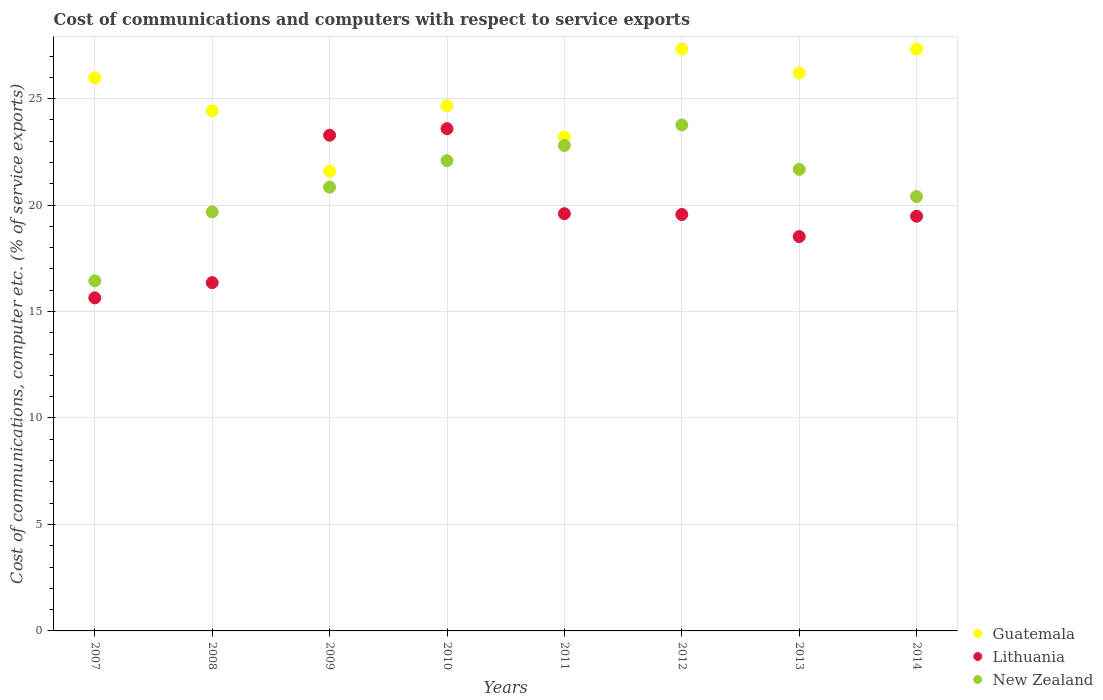Is the number of dotlines equal to the number of legend labels?
Provide a short and direct response. Yes. What is the cost of communications and computers in New Zealand in 2014?
Offer a terse response. 20.4. Across all years, what is the maximum cost of communications and computers in Lithuania?
Your answer should be compact. 23.59. Across all years, what is the minimum cost of communications and computers in Lithuania?
Keep it short and to the point. 15.64. What is the total cost of communications and computers in Guatemala in the graph?
Ensure brevity in your answer.  200.71. What is the difference between the cost of communications and computers in Lithuania in 2011 and that in 2013?
Ensure brevity in your answer.  1.08. What is the difference between the cost of communications and computers in New Zealand in 2014 and the cost of communications and computers in Lithuania in 2007?
Your response must be concise. 4.76. What is the average cost of communications and computers in New Zealand per year?
Offer a very short reply. 20.96. In the year 2010, what is the difference between the cost of communications and computers in Lithuania and cost of communications and computers in New Zealand?
Give a very brief answer. 1.5. What is the ratio of the cost of communications and computers in Lithuania in 2007 to that in 2009?
Your answer should be compact. 0.67. Is the difference between the cost of communications and computers in Lithuania in 2009 and 2013 greater than the difference between the cost of communications and computers in New Zealand in 2009 and 2013?
Your answer should be very brief. Yes. What is the difference between the highest and the second highest cost of communications and computers in New Zealand?
Make the answer very short. 0.96. What is the difference between the highest and the lowest cost of communications and computers in New Zealand?
Your response must be concise. 7.32. Is it the case that in every year, the sum of the cost of communications and computers in Guatemala and cost of communications and computers in New Zealand  is greater than the cost of communications and computers in Lithuania?
Provide a short and direct response. Yes. Is the cost of communications and computers in Guatemala strictly greater than the cost of communications and computers in New Zealand over the years?
Your answer should be very brief. Yes. How many dotlines are there?
Offer a terse response. 3. How many years are there in the graph?
Your answer should be very brief. 8. Are the values on the major ticks of Y-axis written in scientific E-notation?
Your response must be concise. No. How are the legend labels stacked?
Your answer should be very brief. Vertical. What is the title of the graph?
Give a very brief answer. Cost of communications and computers with respect to service exports. Does "Middle income" appear as one of the legend labels in the graph?
Your answer should be very brief. No. What is the label or title of the Y-axis?
Give a very brief answer. Cost of communications, computer etc. (% of service exports). What is the Cost of communications, computer etc. (% of service exports) of Guatemala in 2007?
Your answer should be compact. 25.98. What is the Cost of communications, computer etc. (% of service exports) in Lithuania in 2007?
Offer a terse response. 15.64. What is the Cost of communications, computer etc. (% of service exports) in New Zealand in 2007?
Offer a very short reply. 16.44. What is the Cost of communications, computer etc. (% of service exports) in Guatemala in 2008?
Your answer should be compact. 24.42. What is the Cost of communications, computer etc. (% of service exports) of Lithuania in 2008?
Provide a short and direct response. 16.36. What is the Cost of communications, computer etc. (% of service exports) of New Zealand in 2008?
Give a very brief answer. 19.68. What is the Cost of communications, computer etc. (% of service exports) of Guatemala in 2009?
Ensure brevity in your answer.  21.59. What is the Cost of communications, computer etc. (% of service exports) of Lithuania in 2009?
Provide a succinct answer. 23.28. What is the Cost of communications, computer etc. (% of service exports) in New Zealand in 2009?
Ensure brevity in your answer.  20.84. What is the Cost of communications, computer etc. (% of service exports) in Guatemala in 2010?
Your answer should be compact. 24.66. What is the Cost of communications, computer etc. (% of service exports) of Lithuania in 2010?
Give a very brief answer. 23.59. What is the Cost of communications, computer etc. (% of service exports) of New Zealand in 2010?
Your answer should be very brief. 22.08. What is the Cost of communications, computer etc. (% of service exports) in Guatemala in 2011?
Ensure brevity in your answer.  23.2. What is the Cost of communications, computer etc. (% of service exports) of Lithuania in 2011?
Offer a terse response. 19.6. What is the Cost of communications, computer etc. (% of service exports) in New Zealand in 2011?
Provide a succinct answer. 22.8. What is the Cost of communications, computer etc. (% of service exports) of Guatemala in 2012?
Give a very brief answer. 27.33. What is the Cost of communications, computer etc. (% of service exports) in Lithuania in 2012?
Offer a very short reply. 19.56. What is the Cost of communications, computer etc. (% of service exports) of New Zealand in 2012?
Your answer should be very brief. 23.76. What is the Cost of communications, computer etc. (% of service exports) in Guatemala in 2013?
Your answer should be compact. 26.2. What is the Cost of communications, computer etc. (% of service exports) in Lithuania in 2013?
Your response must be concise. 18.52. What is the Cost of communications, computer etc. (% of service exports) of New Zealand in 2013?
Offer a very short reply. 21.68. What is the Cost of communications, computer etc. (% of service exports) of Guatemala in 2014?
Your answer should be very brief. 27.33. What is the Cost of communications, computer etc. (% of service exports) of Lithuania in 2014?
Offer a terse response. 19.48. What is the Cost of communications, computer etc. (% of service exports) in New Zealand in 2014?
Ensure brevity in your answer.  20.4. Across all years, what is the maximum Cost of communications, computer etc. (% of service exports) in Guatemala?
Your answer should be very brief. 27.33. Across all years, what is the maximum Cost of communications, computer etc. (% of service exports) of Lithuania?
Keep it short and to the point. 23.59. Across all years, what is the maximum Cost of communications, computer etc. (% of service exports) of New Zealand?
Ensure brevity in your answer.  23.76. Across all years, what is the minimum Cost of communications, computer etc. (% of service exports) of Guatemala?
Provide a short and direct response. 21.59. Across all years, what is the minimum Cost of communications, computer etc. (% of service exports) of Lithuania?
Provide a short and direct response. 15.64. Across all years, what is the minimum Cost of communications, computer etc. (% of service exports) of New Zealand?
Make the answer very short. 16.44. What is the total Cost of communications, computer etc. (% of service exports) of Guatemala in the graph?
Offer a terse response. 200.71. What is the total Cost of communications, computer etc. (% of service exports) of Lithuania in the graph?
Offer a very short reply. 156.01. What is the total Cost of communications, computer etc. (% of service exports) of New Zealand in the graph?
Offer a terse response. 167.68. What is the difference between the Cost of communications, computer etc. (% of service exports) in Guatemala in 2007 and that in 2008?
Provide a succinct answer. 1.55. What is the difference between the Cost of communications, computer etc. (% of service exports) of Lithuania in 2007 and that in 2008?
Ensure brevity in your answer.  -0.71. What is the difference between the Cost of communications, computer etc. (% of service exports) in New Zealand in 2007 and that in 2008?
Keep it short and to the point. -3.24. What is the difference between the Cost of communications, computer etc. (% of service exports) in Guatemala in 2007 and that in 2009?
Offer a terse response. 4.38. What is the difference between the Cost of communications, computer etc. (% of service exports) of Lithuania in 2007 and that in 2009?
Provide a succinct answer. -7.64. What is the difference between the Cost of communications, computer etc. (% of service exports) of New Zealand in 2007 and that in 2009?
Give a very brief answer. -4.4. What is the difference between the Cost of communications, computer etc. (% of service exports) in Guatemala in 2007 and that in 2010?
Provide a succinct answer. 1.31. What is the difference between the Cost of communications, computer etc. (% of service exports) in Lithuania in 2007 and that in 2010?
Provide a short and direct response. -7.94. What is the difference between the Cost of communications, computer etc. (% of service exports) in New Zealand in 2007 and that in 2010?
Your answer should be compact. -5.64. What is the difference between the Cost of communications, computer etc. (% of service exports) in Guatemala in 2007 and that in 2011?
Provide a short and direct response. 2.78. What is the difference between the Cost of communications, computer etc. (% of service exports) in Lithuania in 2007 and that in 2011?
Give a very brief answer. -3.95. What is the difference between the Cost of communications, computer etc. (% of service exports) in New Zealand in 2007 and that in 2011?
Provide a short and direct response. -6.36. What is the difference between the Cost of communications, computer etc. (% of service exports) in Guatemala in 2007 and that in 2012?
Provide a succinct answer. -1.35. What is the difference between the Cost of communications, computer etc. (% of service exports) in Lithuania in 2007 and that in 2012?
Make the answer very short. -3.91. What is the difference between the Cost of communications, computer etc. (% of service exports) in New Zealand in 2007 and that in 2012?
Keep it short and to the point. -7.32. What is the difference between the Cost of communications, computer etc. (% of service exports) in Guatemala in 2007 and that in 2013?
Your answer should be compact. -0.23. What is the difference between the Cost of communications, computer etc. (% of service exports) of Lithuania in 2007 and that in 2013?
Your response must be concise. -2.88. What is the difference between the Cost of communications, computer etc. (% of service exports) of New Zealand in 2007 and that in 2013?
Give a very brief answer. -5.24. What is the difference between the Cost of communications, computer etc. (% of service exports) in Guatemala in 2007 and that in 2014?
Give a very brief answer. -1.35. What is the difference between the Cost of communications, computer etc. (% of service exports) in Lithuania in 2007 and that in 2014?
Offer a very short reply. -3.83. What is the difference between the Cost of communications, computer etc. (% of service exports) of New Zealand in 2007 and that in 2014?
Provide a short and direct response. -3.96. What is the difference between the Cost of communications, computer etc. (% of service exports) in Guatemala in 2008 and that in 2009?
Your answer should be very brief. 2.83. What is the difference between the Cost of communications, computer etc. (% of service exports) in Lithuania in 2008 and that in 2009?
Your answer should be very brief. -6.92. What is the difference between the Cost of communications, computer etc. (% of service exports) in New Zealand in 2008 and that in 2009?
Provide a short and direct response. -1.16. What is the difference between the Cost of communications, computer etc. (% of service exports) in Guatemala in 2008 and that in 2010?
Offer a terse response. -0.24. What is the difference between the Cost of communications, computer etc. (% of service exports) in Lithuania in 2008 and that in 2010?
Provide a short and direct response. -7.23. What is the difference between the Cost of communications, computer etc. (% of service exports) of New Zealand in 2008 and that in 2010?
Offer a very short reply. -2.4. What is the difference between the Cost of communications, computer etc. (% of service exports) in Guatemala in 2008 and that in 2011?
Give a very brief answer. 1.22. What is the difference between the Cost of communications, computer etc. (% of service exports) in Lithuania in 2008 and that in 2011?
Your answer should be compact. -3.24. What is the difference between the Cost of communications, computer etc. (% of service exports) of New Zealand in 2008 and that in 2011?
Make the answer very short. -3.12. What is the difference between the Cost of communications, computer etc. (% of service exports) in Guatemala in 2008 and that in 2012?
Your response must be concise. -2.91. What is the difference between the Cost of communications, computer etc. (% of service exports) in Lithuania in 2008 and that in 2012?
Provide a succinct answer. -3.2. What is the difference between the Cost of communications, computer etc. (% of service exports) in New Zealand in 2008 and that in 2012?
Make the answer very short. -4.08. What is the difference between the Cost of communications, computer etc. (% of service exports) of Guatemala in 2008 and that in 2013?
Give a very brief answer. -1.78. What is the difference between the Cost of communications, computer etc. (% of service exports) of Lithuania in 2008 and that in 2013?
Keep it short and to the point. -2.16. What is the difference between the Cost of communications, computer etc. (% of service exports) of New Zealand in 2008 and that in 2013?
Offer a terse response. -2. What is the difference between the Cost of communications, computer etc. (% of service exports) in Guatemala in 2008 and that in 2014?
Your response must be concise. -2.9. What is the difference between the Cost of communications, computer etc. (% of service exports) of Lithuania in 2008 and that in 2014?
Provide a succinct answer. -3.12. What is the difference between the Cost of communications, computer etc. (% of service exports) of New Zealand in 2008 and that in 2014?
Your response must be concise. -0.72. What is the difference between the Cost of communications, computer etc. (% of service exports) in Guatemala in 2009 and that in 2010?
Make the answer very short. -3.07. What is the difference between the Cost of communications, computer etc. (% of service exports) in Lithuania in 2009 and that in 2010?
Ensure brevity in your answer.  -0.31. What is the difference between the Cost of communications, computer etc. (% of service exports) of New Zealand in 2009 and that in 2010?
Your answer should be very brief. -1.24. What is the difference between the Cost of communications, computer etc. (% of service exports) of Guatemala in 2009 and that in 2011?
Provide a short and direct response. -1.61. What is the difference between the Cost of communications, computer etc. (% of service exports) of Lithuania in 2009 and that in 2011?
Your answer should be very brief. 3.69. What is the difference between the Cost of communications, computer etc. (% of service exports) of New Zealand in 2009 and that in 2011?
Offer a terse response. -1.96. What is the difference between the Cost of communications, computer etc. (% of service exports) in Guatemala in 2009 and that in 2012?
Provide a short and direct response. -5.74. What is the difference between the Cost of communications, computer etc. (% of service exports) of Lithuania in 2009 and that in 2012?
Your answer should be compact. 3.72. What is the difference between the Cost of communications, computer etc. (% of service exports) of New Zealand in 2009 and that in 2012?
Make the answer very short. -2.92. What is the difference between the Cost of communications, computer etc. (% of service exports) of Guatemala in 2009 and that in 2013?
Offer a terse response. -4.61. What is the difference between the Cost of communications, computer etc. (% of service exports) in Lithuania in 2009 and that in 2013?
Give a very brief answer. 4.76. What is the difference between the Cost of communications, computer etc. (% of service exports) in New Zealand in 2009 and that in 2013?
Keep it short and to the point. -0.84. What is the difference between the Cost of communications, computer etc. (% of service exports) in Guatemala in 2009 and that in 2014?
Your answer should be very brief. -5.74. What is the difference between the Cost of communications, computer etc. (% of service exports) of Lithuania in 2009 and that in 2014?
Make the answer very short. 3.81. What is the difference between the Cost of communications, computer etc. (% of service exports) of New Zealand in 2009 and that in 2014?
Give a very brief answer. 0.44. What is the difference between the Cost of communications, computer etc. (% of service exports) in Guatemala in 2010 and that in 2011?
Offer a terse response. 1.47. What is the difference between the Cost of communications, computer etc. (% of service exports) in Lithuania in 2010 and that in 2011?
Make the answer very short. 3.99. What is the difference between the Cost of communications, computer etc. (% of service exports) in New Zealand in 2010 and that in 2011?
Make the answer very short. -0.72. What is the difference between the Cost of communications, computer etc. (% of service exports) of Guatemala in 2010 and that in 2012?
Your answer should be very brief. -2.67. What is the difference between the Cost of communications, computer etc. (% of service exports) in Lithuania in 2010 and that in 2012?
Provide a short and direct response. 4.03. What is the difference between the Cost of communications, computer etc. (% of service exports) in New Zealand in 2010 and that in 2012?
Ensure brevity in your answer.  -1.68. What is the difference between the Cost of communications, computer etc. (% of service exports) of Guatemala in 2010 and that in 2013?
Give a very brief answer. -1.54. What is the difference between the Cost of communications, computer etc. (% of service exports) of Lithuania in 2010 and that in 2013?
Provide a succinct answer. 5.07. What is the difference between the Cost of communications, computer etc. (% of service exports) in New Zealand in 2010 and that in 2013?
Keep it short and to the point. 0.41. What is the difference between the Cost of communications, computer etc. (% of service exports) in Guatemala in 2010 and that in 2014?
Keep it short and to the point. -2.66. What is the difference between the Cost of communications, computer etc. (% of service exports) of Lithuania in 2010 and that in 2014?
Give a very brief answer. 4.11. What is the difference between the Cost of communications, computer etc. (% of service exports) in New Zealand in 2010 and that in 2014?
Provide a short and direct response. 1.68. What is the difference between the Cost of communications, computer etc. (% of service exports) in Guatemala in 2011 and that in 2012?
Provide a short and direct response. -4.13. What is the difference between the Cost of communications, computer etc. (% of service exports) in Lithuania in 2011 and that in 2012?
Give a very brief answer. 0.04. What is the difference between the Cost of communications, computer etc. (% of service exports) of New Zealand in 2011 and that in 2012?
Your answer should be very brief. -0.96. What is the difference between the Cost of communications, computer etc. (% of service exports) of Guatemala in 2011 and that in 2013?
Provide a succinct answer. -3.01. What is the difference between the Cost of communications, computer etc. (% of service exports) in Lithuania in 2011 and that in 2013?
Offer a very short reply. 1.08. What is the difference between the Cost of communications, computer etc. (% of service exports) in New Zealand in 2011 and that in 2013?
Give a very brief answer. 1.12. What is the difference between the Cost of communications, computer etc. (% of service exports) in Guatemala in 2011 and that in 2014?
Your answer should be very brief. -4.13. What is the difference between the Cost of communications, computer etc. (% of service exports) of Lithuania in 2011 and that in 2014?
Offer a terse response. 0.12. What is the difference between the Cost of communications, computer etc. (% of service exports) of New Zealand in 2011 and that in 2014?
Ensure brevity in your answer.  2.4. What is the difference between the Cost of communications, computer etc. (% of service exports) of Lithuania in 2012 and that in 2013?
Offer a terse response. 1.04. What is the difference between the Cost of communications, computer etc. (% of service exports) of New Zealand in 2012 and that in 2013?
Offer a very short reply. 2.08. What is the difference between the Cost of communications, computer etc. (% of service exports) of Guatemala in 2012 and that in 2014?
Give a very brief answer. 0. What is the difference between the Cost of communications, computer etc. (% of service exports) of Lithuania in 2012 and that in 2014?
Your answer should be compact. 0.08. What is the difference between the Cost of communications, computer etc. (% of service exports) in New Zealand in 2012 and that in 2014?
Give a very brief answer. 3.36. What is the difference between the Cost of communications, computer etc. (% of service exports) in Guatemala in 2013 and that in 2014?
Your response must be concise. -1.12. What is the difference between the Cost of communications, computer etc. (% of service exports) of Lithuania in 2013 and that in 2014?
Provide a short and direct response. -0.96. What is the difference between the Cost of communications, computer etc. (% of service exports) in New Zealand in 2013 and that in 2014?
Provide a short and direct response. 1.28. What is the difference between the Cost of communications, computer etc. (% of service exports) in Guatemala in 2007 and the Cost of communications, computer etc. (% of service exports) in Lithuania in 2008?
Provide a short and direct response. 9.62. What is the difference between the Cost of communications, computer etc. (% of service exports) in Guatemala in 2007 and the Cost of communications, computer etc. (% of service exports) in New Zealand in 2008?
Make the answer very short. 6.3. What is the difference between the Cost of communications, computer etc. (% of service exports) in Lithuania in 2007 and the Cost of communications, computer etc. (% of service exports) in New Zealand in 2008?
Your answer should be very brief. -4.04. What is the difference between the Cost of communications, computer etc. (% of service exports) of Guatemala in 2007 and the Cost of communications, computer etc. (% of service exports) of Lithuania in 2009?
Offer a very short reply. 2.7. What is the difference between the Cost of communications, computer etc. (% of service exports) in Guatemala in 2007 and the Cost of communications, computer etc. (% of service exports) in New Zealand in 2009?
Ensure brevity in your answer.  5.14. What is the difference between the Cost of communications, computer etc. (% of service exports) in Lithuania in 2007 and the Cost of communications, computer etc. (% of service exports) in New Zealand in 2009?
Your answer should be compact. -5.2. What is the difference between the Cost of communications, computer etc. (% of service exports) of Guatemala in 2007 and the Cost of communications, computer etc. (% of service exports) of Lithuania in 2010?
Keep it short and to the point. 2.39. What is the difference between the Cost of communications, computer etc. (% of service exports) in Guatemala in 2007 and the Cost of communications, computer etc. (% of service exports) in New Zealand in 2010?
Your response must be concise. 3.89. What is the difference between the Cost of communications, computer etc. (% of service exports) of Lithuania in 2007 and the Cost of communications, computer etc. (% of service exports) of New Zealand in 2010?
Your response must be concise. -6.44. What is the difference between the Cost of communications, computer etc. (% of service exports) of Guatemala in 2007 and the Cost of communications, computer etc. (% of service exports) of Lithuania in 2011?
Your answer should be compact. 6.38. What is the difference between the Cost of communications, computer etc. (% of service exports) of Guatemala in 2007 and the Cost of communications, computer etc. (% of service exports) of New Zealand in 2011?
Offer a very short reply. 3.18. What is the difference between the Cost of communications, computer etc. (% of service exports) in Lithuania in 2007 and the Cost of communications, computer etc. (% of service exports) in New Zealand in 2011?
Provide a short and direct response. -7.16. What is the difference between the Cost of communications, computer etc. (% of service exports) of Guatemala in 2007 and the Cost of communications, computer etc. (% of service exports) of Lithuania in 2012?
Make the answer very short. 6.42. What is the difference between the Cost of communications, computer etc. (% of service exports) in Guatemala in 2007 and the Cost of communications, computer etc. (% of service exports) in New Zealand in 2012?
Keep it short and to the point. 2.22. What is the difference between the Cost of communications, computer etc. (% of service exports) of Lithuania in 2007 and the Cost of communications, computer etc. (% of service exports) of New Zealand in 2012?
Make the answer very short. -8.12. What is the difference between the Cost of communications, computer etc. (% of service exports) of Guatemala in 2007 and the Cost of communications, computer etc. (% of service exports) of Lithuania in 2013?
Your answer should be compact. 7.46. What is the difference between the Cost of communications, computer etc. (% of service exports) in Guatemala in 2007 and the Cost of communications, computer etc. (% of service exports) in New Zealand in 2013?
Your answer should be compact. 4.3. What is the difference between the Cost of communications, computer etc. (% of service exports) in Lithuania in 2007 and the Cost of communications, computer etc. (% of service exports) in New Zealand in 2013?
Give a very brief answer. -6.03. What is the difference between the Cost of communications, computer etc. (% of service exports) in Guatemala in 2007 and the Cost of communications, computer etc. (% of service exports) in Lithuania in 2014?
Keep it short and to the point. 6.5. What is the difference between the Cost of communications, computer etc. (% of service exports) of Guatemala in 2007 and the Cost of communications, computer etc. (% of service exports) of New Zealand in 2014?
Ensure brevity in your answer.  5.58. What is the difference between the Cost of communications, computer etc. (% of service exports) of Lithuania in 2007 and the Cost of communications, computer etc. (% of service exports) of New Zealand in 2014?
Provide a succinct answer. -4.76. What is the difference between the Cost of communications, computer etc. (% of service exports) of Guatemala in 2008 and the Cost of communications, computer etc. (% of service exports) of New Zealand in 2009?
Provide a short and direct response. 3.58. What is the difference between the Cost of communications, computer etc. (% of service exports) of Lithuania in 2008 and the Cost of communications, computer etc. (% of service exports) of New Zealand in 2009?
Provide a short and direct response. -4.48. What is the difference between the Cost of communications, computer etc. (% of service exports) of Guatemala in 2008 and the Cost of communications, computer etc. (% of service exports) of Lithuania in 2010?
Offer a very short reply. 0.84. What is the difference between the Cost of communications, computer etc. (% of service exports) in Guatemala in 2008 and the Cost of communications, computer etc. (% of service exports) in New Zealand in 2010?
Offer a terse response. 2.34. What is the difference between the Cost of communications, computer etc. (% of service exports) of Lithuania in 2008 and the Cost of communications, computer etc. (% of service exports) of New Zealand in 2010?
Your answer should be very brief. -5.73. What is the difference between the Cost of communications, computer etc. (% of service exports) in Guatemala in 2008 and the Cost of communications, computer etc. (% of service exports) in Lithuania in 2011?
Offer a very short reply. 4.83. What is the difference between the Cost of communications, computer etc. (% of service exports) in Guatemala in 2008 and the Cost of communications, computer etc. (% of service exports) in New Zealand in 2011?
Ensure brevity in your answer.  1.62. What is the difference between the Cost of communications, computer etc. (% of service exports) of Lithuania in 2008 and the Cost of communications, computer etc. (% of service exports) of New Zealand in 2011?
Provide a short and direct response. -6.44. What is the difference between the Cost of communications, computer etc. (% of service exports) in Guatemala in 2008 and the Cost of communications, computer etc. (% of service exports) in Lithuania in 2012?
Give a very brief answer. 4.87. What is the difference between the Cost of communications, computer etc. (% of service exports) of Guatemala in 2008 and the Cost of communications, computer etc. (% of service exports) of New Zealand in 2012?
Ensure brevity in your answer.  0.66. What is the difference between the Cost of communications, computer etc. (% of service exports) of Lithuania in 2008 and the Cost of communications, computer etc. (% of service exports) of New Zealand in 2012?
Your response must be concise. -7.4. What is the difference between the Cost of communications, computer etc. (% of service exports) of Guatemala in 2008 and the Cost of communications, computer etc. (% of service exports) of Lithuania in 2013?
Make the answer very short. 5.9. What is the difference between the Cost of communications, computer etc. (% of service exports) in Guatemala in 2008 and the Cost of communications, computer etc. (% of service exports) in New Zealand in 2013?
Offer a very short reply. 2.75. What is the difference between the Cost of communications, computer etc. (% of service exports) in Lithuania in 2008 and the Cost of communications, computer etc. (% of service exports) in New Zealand in 2013?
Make the answer very short. -5.32. What is the difference between the Cost of communications, computer etc. (% of service exports) of Guatemala in 2008 and the Cost of communications, computer etc. (% of service exports) of Lithuania in 2014?
Your answer should be compact. 4.95. What is the difference between the Cost of communications, computer etc. (% of service exports) of Guatemala in 2008 and the Cost of communications, computer etc. (% of service exports) of New Zealand in 2014?
Make the answer very short. 4.02. What is the difference between the Cost of communications, computer etc. (% of service exports) of Lithuania in 2008 and the Cost of communications, computer etc. (% of service exports) of New Zealand in 2014?
Keep it short and to the point. -4.04. What is the difference between the Cost of communications, computer etc. (% of service exports) of Guatemala in 2009 and the Cost of communications, computer etc. (% of service exports) of Lithuania in 2010?
Offer a very short reply. -2. What is the difference between the Cost of communications, computer etc. (% of service exports) in Guatemala in 2009 and the Cost of communications, computer etc. (% of service exports) in New Zealand in 2010?
Your response must be concise. -0.49. What is the difference between the Cost of communications, computer etc. (% of service exports) of Lithuania in 2009 and the Cost of communications, computer etc. (% of service exports) of New Zealand in 2010?
Provide a succinct answer. 1.2. What is the difference between the Cost of communications, computer etc. (% of service exports) of Guatemala in 2009 and the Cost of communications, computer etc. (% of service exports) of Lithuania in 2011?
Provide a succinct answer. 2. What is the difference between the Cost of communications, computer etc. (% of service exports) of Guatemala in 2009 and the Cost of communications, computer etc. (% of service exports) of New Zealand in 2011?
Give a very brief answer. -1.21. What is the difference between the Cost of communications, computer etc. (% of service exports) in Lithuania in 2009 and the Cost of communications, computer etc. (% of service exports) in New Zealand in 2011?
Provide a short and direct response. 0.48. What is the difference between the Cost of communications, computer etc. (% of service exports) in Guatemala in 2009 and the Cost of communications, computer etc. (% of service exports) in Lithuania in 2012?
Your answer should be very brief. 2.03. What is the difference between the Cost of communications, computer etc. (% of service exports) of Guatemala in 2009 and the Cost of communications, computer etc. (% of service exports) of New Zealand in 2012?
Provide a succinct answer. -2.17. What is the difference between the Cost of communications, computer etc. (% of service exports) in Lithuania in 2009 and the Cost of communications, computer etc. (% of service exports) in New Zealand in 2012?
Provide a short and direct response. -0.48. What is the difference between the Cost of communications, computer etc. (% of service exports) in Guatemala in 2009 and the Cost of communications, computer etc. (% of service exports) in Lithuania in 2013?
Give a very brief answer. 3.07. What is the difference between the Cost of communications, computer etc. (% of service exports) of Guatemala in 2009 and the Cost of communications, computer etc. (% of service exports) of New Zealand in 2013?
Your answer should be very brief. -0.09. What is the difference between the Cost of communications, computer etc. (% of service exports) of Lithuania in 2009 and the Cost of communications, computer etc. (% of service exports) of New Zealand in 2013?
Your answer should be very brief. 1.6. What is the difference between the Cost of communications, computer etc. (% of service exports) in Guatemala in 2009 and the Cost of communications, computer etc. (% of service exports) in Lithuania in 2014?
Offer a terse response. 2.12. What is the difference between the Cost of communications, computer etc. (% of service exports) of Guatemala in 2009 and the Cost of communications, computer etc. (% of service exports) of New Zealand in 2014?
Make the answer very short. 1.19. What is the difference between the Cost of communications, computer etc. (% of service exports) of Lithuania in 2009 and the Cost of communications, computer etc. (% of service exports) of New Zealand in 2014?
Provide a short and direct response. 2.88. What is the difference between the Cost of communications, computer etc. (% of service exports) of Guatemala in 2010 and the Cost of communications, computer etc. (% of service exports) of Lithuania in 2011?
Give a very brief answer. 5.07. What is the difference between the Cost of communications, computer etc. (% of service exports) in Guatemala in 2010 and the Cost of communications, computer etc. (% of service exports) in New Zealand in 2011?
Provide a short and direct response. 1.86. What is the difference between the Cost of communications, computer etc. (% of service exports) of Lithuania in 2010 and the Cost of communications, computer etc. (% of service exports) of New Zealand in 2011?
Your response must be concise. 0.79. What is the difference between the Cost of communications, computer etc. (% of service exports) in Guatemala in 2010 and the Cost of communications, computer etc. (% of service exports) in Lithuania in 2012?
Your response must be concise. 5.11. What is the difference between the Cost of communications, computer etc. (% of service exports) in Guatemala in 2010 and the Cost of communications, computer etc. (% of service exports) in New Zealand in 2012?
Make the answer very short. 0.9. What is the difference between the Cost of communications, computer etc. (% of service exports) in Lithuania in 2010 and the Cost of communications, computer etc. (% of service exports) in New Zealand in 2012?
Offer a terse response. -0.17. What is the difference between the Cost of communications, computer etc. (% of service exports) of Guatemala in 2010 and the Cost of communications, computer etc. (% of service exports) of Lithuania in 2013?
Your answer should be compact. 6.14. What is the difference between the Cost of communications, computer etc. (% of service exports) in Guatemala in 2010 and the Cost of communications, computer etc. (% of service exports) in New Zealand in 2013?
Your response must be concise. 2.99. What is the difference between the Cost of communications, computer etc. (% of service exports) of Lithuania in 2010 and the Cost of communications, computer etc. (% of service exports) of New Zealand in 2013?
Offer a terse response. 1.91. What is the difference between the Cost of communications, computer etc. (% of service exports) in Guatemala in 2010 and the Cost of communications, computer etc. (% of service exports) in Lithuania in 2014?
Keep it short and to the point. 5.19. What is the difference between the Cost of communications, computer etc. (% of service exports) of Guatemala in 2010 and the Cost of communications, computer etc. (% of service exports) of New Zealand in 2014?
Offer a very short reply. 4.26. What is the difference between the Cost of communications, computer etc. (% of service exports) in Lithuania in 2010 and the Cost of communications, computer etc. (% of service exports) in New Zealand in 2014?
Make the answer very short. 3.19. What is the difference between the Cost of communications, computer etc. (% of service exports) of Guatemala in 2011 and the Cost of communications, computer etc. (% of service exports) of Lithuania in 2012?
Provide a short and direct response. 3.64. What is the difference between the Cost of communications, computer etc. (% of service exports) in Guatemala in 2011 and the Cost of communications, computer etc. (% of service exports) in New Zealand in 2012?
Give a very brief answer. -0.56. What is the difference between the Cost of communications, computer etc. (% of service exports) of Lithuania in 2011 and the Cost of communications, computer etc. (% of service exports) of New Zealand in 2012?
Provide a succinct answer. -4.17. What is the difference between the Cost of communications, computer etc. (% of service exports) of Guatemala in 2011 and the Cost of communications, computer etc. (% of service exports) of Lithuania in 2013?
Make the answer very short. 4.68. What is the difference between the Cost of communications, computer etc. (% of service exports) of Guatemala in 2011 and the Cost of communications, computer etc. (% of service exports) of New Zealand in 2013?
Offer a very short reply. 1.52. What is the difference between the Cost of communications, computer etc. (% of service exports) of Lithuania in 2011 and the Cost of communications, computer etc. (% of service exports) of New Zealand in 2013?
Your answer should be compact. -2.08. What is the difference between the Cost of communications, computer etc. (% of service exports) in Guatemala in 2011 and the Cost of communications, computer etc. (% of service exports) in Lithuania in 2014?
Ensure brevity in your answer.  3.72. What is the difference between the Cost of communications, computer etc. (% of service exports) of Guatemala in 2011 and the Cost of communications, computer etc. (% of service exports) of New Zealand in 2014?
Your answer should be very brief. 2.8. What is the difference between the Cost of communications, computer etc. (% of service exports) of Lithuania in 2011 and the Cost of communications, computer etc. (% of service exports) of New Zealand in 2014?
Offer a terse response. -0.8. What is the difference between the Cost of communications, computer etc. (% of service exports) in Guatemala in 2012 and the Cost of communications, computer etc. (% of service exports) in Lithuania in 2013?
Your answer should be compact. 8.81. What is the difference between the Cost of communications, computer etc. (% of service exports) of Guatemala in 2012 and the Cost of communications, computer etc. (% of service exports) of New Zealand in 2013?
Offer a very short reply. 5.65. What is the difference between the Cost of communications, computer etc. (% of service exports) in Lithuania in 2012 and the Cost of communications, computer etc. (% of service exports) in New Zealand in 2013?
Offer a very short reply. -2.12. What is the difference between the Cost of communications, computer etc. (% of service exports) of Guatemala in 2012 and the Cost of communications, computer etc. (% of service exports) of Lithuania in 2014?
Your answer should be compact. 7.85. What is the difference between the Cost of communications, computer etc. (% of service exports) in Guatemala in 2012 and the Cost of communications, computer etc. (% of service exports) in New Zealand in 2014?
Your answer should be compact. 6.93. What is the difference between the Cost of communications, computer etc. (% of service exports) in Lithuania in 2012 and the Cost of communications, computer etc. (% of service exports) in New Zealand in 2014?
Give a very brief answer. -0.84. What is the difference between the Cost of communications, computer etc. (% of service exports) in Guatemala in 2013 and the Cost of communications, computer etc. (% of service exports) in Lithuania in 2014?
Your response must be concise. 6.73. What is the difference between the Cost of communications, computer etc. (% of service exports) in Guatemala in 2013 and the Cost of communications, computer etc. (% of service exports) in New Zealand in 2014?
Provide a short and direct response. 5.8. What is the difference between the Cost of communications, computer etc. (% of service exports) of Lithuania in 2013 and the Cost of communications, computer etc. (% of service exports) of New Zealand in 2014?
Give a very brief answer. -1.88. What is the average Cost of communications, computer etc. (% of service exports) in Guatemala per year?
Provide a short and direct response. 25.09. What is the average Cost of communications, computer etc. (% of service exports) in Lithuania per year?
Keep it short and to the point. 19.5. What is the average Cost of communications, computer etc. (% of service exports) of New Zealand per year?
Provide a succinct answer. 20.96. In the year 2007, what is the difference between the Cost of communications, computer etc. (% of service exports) of Guatemala and Cost of communications, computer etc. (% of service exports) of Lithuania?
Provide a short and direct response. 10.33. In the year 2007, what is the difference between the Cost of communications, computer etc. (% of service exports) of Guatemala and Cost of communications, computer etc. (% of service exports) of New Zealand?
Your answer should be compact. 9.54. In the year 2007, what is the difference between the Cost of communications, computer etc. (% of service exports) of Lithuania and Cost of communications, computer etc. (% of service exports) of New Zealand?
Keep it short and to the point. -0.8. In the year 2008, what is the difference between the Cost of communications, computer etc. (% of service exports) in Guatemala and Cost of communications, computer etc. (% of service exports) in Lithuania?
Offer a very short reply. 8.07. In the year 2008, what is the difference between the Cost of communications, computer etc. (% of service exports) of Guatemala and Cost of communications, computer etc. (% of service exports) of New Zealand?
Give a very brief answer. 4.74. In the year 2008, what is the difference between the Cost of communications, computer etc. (% of service exports) of Lithuania and Cost of communications, computer etc. (% of service exports) of New Zealand?
Your response must be concise. -3.32. In the year 2009, what is the difference between the Cost of communications, computer etc. (% of service exports) in Guatemala and Cost of communications, computer etc. (% of service exports) in Lithuania?
Your answer should be very brief. -1.69. In the year 2009, what is the difference between the Cost of communications, computer etc. (% of service exports) of Guatemala and Cost of communications, computer etc. (% of service exports) of New Zealand?
Your answer should be very brief. 0.75. In the year 2009, what is the difference between the Cost of communications, computer etc. (% of service exports) of Lithuania and Cost of communications, computer etc. (% of service exports) of New Zealand?
Ensure brevity in your answer.  2.44. In the year 2010, what is the difference between the Cost of communications, computer etc. (% of service exports) of Guatemala and Cost of communications, computer etc. (% of service exports) of Lithuania?
Your answer should be compact. 1.08. In the year 2010, what is the difference between the Cost of communications, computer etc. (% of service exports) of Guatemala and Cost of communications, computer etc. (% of service exports) of New Zealand?
Offer a very short reply. 2.58. In the year 2010, what is the difference between the Cost of communications, computer etc. (% of service exports) in Lithuania and Cost of communications, computer etc. (% of service exports) in New Zealand?
Your answer should be compact. 1.5. In the year 2011, what is the difference between the Cost of communications, computer etc. (% of service exports) of Guatemala and Cost of communications, computer etc. (% of service exports) of Lithuania?
Offer a terse response. 3.6. In the year 2011, what is the difference between the Cost of communications, computer etc. (% of service exports) of Guatemala and Cost of communications, computer etc. (% of service exports) of New Zealand?
Your answer should be compact. 0.4. In the year 2011, what is the difference between the Cost of communications, computer etc. (% of service exports) of Lithuania and Cost of communications, computer etc. (% of service exports) of New Zealand?
Make the answer very short. -3.2. In the year 2012, what is the difference between the Cost of communications, computer etc. (% of service exports) of Guatemala and Cost of communications, computer etc. (% of service exports) of Lithuania?
Your response must be concise. 7.77. In the year 2012, what is the difference between the Cost of communications, computer etc. (% of service exports) of Guatemala and Cost of communications, computer etc. (% of service exports) of New Zealand?
Provide a short and direct response. 3.57. In the year 2012, what is the difference between the Cost of communications, computer etc. (% of service exports) of Lithuania and Cost of communications, computer etc. (% of service exports) of New Zealand?
Make the answer very short. -4.2. In the year 2013, what is the difference between the Cost of communications, computer etc. (% of service exports) of Guatemala and Cost of communications, computer etc. (% of service exports) of Lithuania?
Keep it short and to the point. 7.68. In the year 2013, what is the difference between the Cost of communications, computer etc. (% of service exports) of Guatemala and Cost of communications, computer etc. (% of service exports) of New Zealand?
Your answer should be compact. 4.53. In the year 2013, what is the difference between the Cost of communications, computer etc. (% of service exports) of Lithuania and Cost of communications, computer etc. (% of service exports) of New Zealand?
Provide a succinct answer. -3.16. In the year 2014, what is the difference between the Cost of communications, computer etc. (% of service exports) of Guatemala and Cost of communications, computer etc. (% of service exports) of Lithuania?
Offer a terse response. 7.85. In the year 2014, what is the difference between the Cost of communications, computer etc. (% of service exports) of Guatemala and Cost of communications, computer etc. (% of service exports) of New Zealand?
Offer a terse response. 6.93. In the year 2014, what is the difference between the Cost of communications, computer etc. (% of service exports) of Lithuania and Cost of communications, computer etc. (% of service exports) of New Zealand?
Your answer should be compact. -0.92. What is the ratio of the Cost of communications, computer etc. (% of service exports) in Guatemala in 2007 to that in 2008?
Ensure brevity in your answer.  1.06. What is the ratio of the Cost of communications, computer etc. (% of service exports) in Lithuania in 2007 to that in 2008?
Make the answer very short. 0.96. What is the ratio of the Cost of communications, computer etc. (% of service exports) in New Zealand in 2007 to that in 2008?
Keep it short and to the point. 0.84. What is the ratio of the Cost of communications, computer etc. (% of service exports) in Guatemala in 2007 to that in 2009?
Ensure brevity in your answer.  1.2. What is the ratio of the Cost of communications, computer etc. (% of service exports) in Lithuania in 2007 to that in 2009?
Make the answer very short. 0.67. What is the ratio of the Cost of communications, computer etc. (% of service exports) of New Zealand in 2007 to that in 2009?
Give a very brief answer. 0.79. What is the ratio of the Cost of communications, computer etc. (% of service exports) in Guatemala in 2007 to that in 2010?
Your response must be concise. 1.05. What is the ratio of the Cost of communications, computer etc. (% of service exports) of Lithuania in 2007 to that in 2010?
Your response must be concise. 0.66. What is the ratio of the Cost of communications, computer etc. (% of service exports) in New Zealand in 2007 to that in 2010?
Provide a short and direct response. 0.74. What is the ratio of the Cost of communications, computer etc. (% of service exports) in Guatemala in 2007 to that in 2011?
Offer a terse response. 1.12. What is the ratio of the Cost of communications, computer etc. (% of service exports) in Lithuania in 2007 to that in 2011?
Offer a very short reply. 0.8. What is the ratio of the Cost of communications, computer etc. (% of service exports) in New Zealand in 2007 to that in 2011?
Make the answer very short. 0.72. What is the ratio of the Cost of communications, computer etc. (% of service exports) of Guatemala in 2007 to that in 2012?
Provide a short and direct response. 0.95. What is the ratio of the Cost of communications, computer etc. (% of service exports) in Lithuania in 2007 to that in 2012?
Your response must be concise. 0.8. What is the ratio of the Cost of communications, computer etc. (% of service exports) in New Zealand in 2007 to that in 2012?
Offer a very short reply. 0.69. What is the ratio of the Cost of communications, computer etc. (% of service exports) of Guatemala in 2007 to that in 2013?
Provide a short and direct response. 0.99. What is the ratio of the Cost of communications, computer etc. (% of service exports) in Lithuania in 2007 to that in 2013?
Ensure brevity in your answer.  0.84. What is the ratio of the Cost of communications, computer etc. (% of service exports) in New Zealand in 2007 to that in 2013?
Your answer should be compact. 0.76. What is the ratio of the Cost of communications, computer etc. (% of service exports) in Guatemala in 2007 to that in 2014?
Ensure brevity in your answer.  0.95. What is the ratio of the Cost of communications, computer etc. (% of service exports) of Lithuania in 2007 to that in 2014?
Offer a terse response. 0.8. What is the ratio of the Cost of communications, computer etc. (% of service exports) of New Zealand in 2007 to that in 2014?
Provide a short and direct response. 0.81. What is the ratio of the Cost of communications, computer etc. (% of service exports) of Guatemala in 2008 to that in 2009?
Provide a short and direct response. 1.13. What is the ratio of the Cost of communications, computer etc. (% of service exports) in Lithuania in 2008 to that in 2009?
Provide a succinct answer. 0.7. What is the ratio of the Cost of communications, computer etc. (% of service exports) in New Zealand in 2008 to that in 2009?
Keep it short and to the point. 0.94. What is the ratio of the Cost of communications, computer etc. (% of service exports) in Guatemala in 2008 to that in 2010?
Ensure brevity in your answer.  0.99. What is the ratio of the Cost of communications, computer etc. (% of service exports) in Lithuania in 2008 to that in 2010?
Ensure brevity in your answer.  0.69. What is the ratio of the Cost of communications, computer etc. (% of service exports) in New Zealand in 2008 to that in 2010?
Keep it short and to the point. 0.89. What is the ratio of the Cost of communications, computer etc. (% of service exports) of Guatemala in 2008 to that in 2011?
Make the answer very short. 1.05. What is the ratio of the Cost of communications, computer etc. (% of service exports) of Lithuania in 2008 to that in 2011?
Give a very brief answer. 0.83. What is the ratio of the Cost of communications, computer etc. (% of service exports) of New Zealand in 2008 to that in 2011?
Keep it short and to the point. 0.86. What is the ratio of the Cost of communications, computer etc. (% of service exports) in Guatemala in 2008 to that in 2012?
Offer a terse response. 0.89. What is the ratio of the Cost of communications, computer etc. (% of service exports) in Lithuania in 2008 to that in 2012?
Provide a succinct answer. 0.84. What is the ratio of the Cost of communications, computer etc. (% of service exports) in New Zealand in 2008 to that in 2012?
Provide a succinct answer. 0.83. What is the ratio of the Cost of communications, computer etc. (% of service exports) of Guatemala in 2008 to that in 2013?
Ensure brevity in your answer.  0.93. What is the ratio of the Cost of communications, computer etc. (% of service exports) in Lithuania in 2008 to that in 2013?
Your answer should be very brief. 0.88. What is the ratio of the Cost of communications, computer etc. (% of service exports) of New Zealand in 2008 to that in 2013?
Provide a succinct answer. 0.91. What is the ratio of the Cost of communications, computer etc. (% of service exports) of Guatemala in 2008 to that in 2014?
Provide a succinct answer. 0.89. What is the ratio of the Cost of communications, computer etc. (% of service exports) in Lithuania in 2008 to that in 2014?
Offer a very short reply. 0.84. What is the ratio of the Cost of communications, computer etc. (% of service exports) of New Zealand in 2008 to that in 2014?
Ensure brevity in your answer.  0.96. What is the ratio of the Cost of communications, computer etc. (% of service exports) of Guatemala in 2009 to that in 2010?
Your answer should be compact. 0.88. What is the ratio of the Cost of communications, computer etc. (% of service exports) in New Zealand in 2009 to that in 2010?
Ensure brevity in your answer.  0.94. What is the ratio of the Cost of communications, computer etc. (% of service exports) in Guatemala in 2009 to that in 2011?
Your answer should be very brief. 0.93. What is the ratio of the Cost of communications, computer etc. (% of service exports) of Lithuania in 2009 to that in 2011?
Provide a short and direct response. 1.19. What is the ratio of the Cost of communications, computer etc. (% of service exports) of New Zealand in 2009 to that in 2011?
Offer a very short reply. 0.91. What is the ratio of the Cost of communications, computer etc. (% of service exports) of Guatemala in 2009 to that in 2012?
Your response must be concise. 0.79. What is the ratio of the Cost of communications, computer etc. (% of service exports) in Lithuania in 2009 to that in 2012?
Make the answer very short. 1.19. What is the ratio of the Cost of communications, computer etc. (% of service exports) of New Zealand in 2009 to that in 2012?
Offer a terse response. 0.88. What is the ratio of the Cost of communications, computer etc. (% of service exports) of Guatemala in 2009 to that in 2013?
Offer a terse response. 0.82. What is the ratio of the Cost of communications, computer etc. (% of service exports) in Lithuania in 2009 to that in 2013?
Offer a very short reply. 1.26. What is the ratio of the Cost of communications, computer etc. (% of service exports) in New Zealand in 2009 to that in 2013?
Your answer should be very brief. 0.96. What is the ratio of the Cost of communications, computer etc. (% of service exports) of Guatemala in 2009 to that in 2014?
Your response must be concise. 0.79. What is the ratio of the Cost of communications, computer etc. (% of service exports) of Lithuania in 2009 to that in 2014?
Provide a succinct answer. 1.2. What is the ratio of the Cost of communications, computer etc. (% of service exports) in New Zealand in 2009 to that in 2014?
Keep it short and to the point. 1.02. What is the ratio of the Cost of communications, computer etc. (% of service exports) in Guatemala in 2010 to that in 2011?
Keep it short and to the point. 1.06. What is the ratio of the Cost of communications, computer etc. (% of service exports) of Lithuania in 2010 to that in 2011?
Make the answer very short. 1.2. What is the ratio of the Cost of communications, computer etc. (% of service exports) in New Zealand in 2010 to that in 2011?
Give a very brief answer. 0.97. What is the ratio of the Cost of communications, computer etc. (% of service exports) of Guatemala in 2010 to that in 2012?
Ensure brevity in your answer.  0.9. What is the ratio of the Cost of communications, computer etc. (% of service exports) of Lithuania in 2010 to that in 2012?
Your answer should be compact. 1.21. What is the ratio of the Cost of communications, computer etc. (% of service exports) in New Zealand in 2010 to that in 2012?
Your answer should be very brief. 0.93. What is the ratio of the Cost of communications, computer etc. (% of service exports) of Guatemala in 2010 to that in 2013?
Your response must be concise. 0.94. What is the ratio of the Cost of communications, computer etc. (% of service exports) of Lithuania in 2010 to that in 2013?
Make the answer very short. 1.27. What is the ratio of the Cost of communications, computer etc. (% of service exports) of New Zealand in 2010 to that in 2013?
Offer a terse response. 1.02. What is the ratio of the Cost of communications, computer etc. (% of service exports) in Guatemala in 2010 to that in 2014?
Offer a very short reply. 0.9. What is the ratio of the Cost of communications, computer etc. (% of service exports) in Lithuania in 2010 to that in 2014?
Ensure brevity in your answer.  1.21. What is the ratio of the Cost of communications, computer etc. (% of service exports) in New Zealand in 2010 to that in 2014?
Provide a succinct answer. 1.08. What is the ratio of the Cost of communications, computer etc. (% of service exports) in Guatemala in 2011 to that in 2012?
Your response must be concise. 0.85. What is the ratio of the Cost of communications, computer etc. (% of service exports) of New Zealand in 2011 to that in 2012?
Offer a very short reply. 0.96. What is the ratio of the Cost of communications, computer etc. (% of service exports) in Guatemala in 2011 to that in 2013?
Give a very brief answer. 0.89. What is the ratio of the Cost of communications, computer etc. (% of service exports) of Lithuania in 2011 to that in 2013?
Your response must be concise. 1.06. What is the ratio of the Cost of communications, computer etc. (% of service exports) of New Zealand in 2011 to that in 2013?
Provide a succinct answer. 1.05. What is the ratio of the Cost of communications, computer etc. (% of service exports) of Guatemala in 2011 to that in 2014?
Ensure brevity in your answer.  0.85. What is the ratio of the Cost of communications, computer etc. (% of service exports) in New Zealand in 2011 to that in 2014?
Ensure brevity in your answer.  1.12. What is the ratio of the Cost of communications, computer etc. (% of service exports) of Guatemala in 2012 to that in 2013?
Provide a short and direct response. 1.04. What is the ratio of the Cost of communications, computer etc. (% of service exports) of Lithuania in 2012 to that in 2013?
Your answer should be very brief. 1.06. What is the ratio of the Cost of communications, computer etc. (% of service exports) of New Zealand in 2012 to that in 2013?
Your answer should be very brief. 1.1. What is the ratio of the Cost of communications, computer etc. (% of service exports) of New Zealand in 2012 to that in 2014?
Offer a very short reply. 1.16. What is the ratio of the Cost of communications, computer etc. (% of service exports) in Guatemala in 2013 to that in 2014?
Provide a succinct answer. 0.96. What is the ratio of the Cost of communications, computer etc. (% of service exports) of Lithuania in 2013 to that in 2014?
Provide a succinct answer. 0.95. What is the ratio of the Cost of communications, computer etc. (% of service exports) in New Zealand in 2013 to that in 2014?
Provide a short and direct response. 1.06. What is the difference between the highest and the second highest Cost of communications, computer etc. (% of service exports) in Guatemala?
Make the answer very short. 0. What is the difference between the highest and the second highest Cost of communications, computer etc. (% of service exports) of Lithuania?
Offer a very short reply. 0.31. What is the difference between the highest and the second highest Cost of communications, computer etc. (% of service exports) of New Zealand?
Provide a short and direct response. 0.96. What is the difference between the highest and the lowest Cost of communications, computer etc. (% of service exports) in Guatemala?
Your answer should be very brief. 5.74. What is the difference between the highest and the lowest Cost of communications, computer etc. (% of service exports) of Lithuania?
Your answer should be compact. 7.94. What is the difference between the highest and the lowest Cost of communications, computer etc. (% of service exports) of New Zealand?
Make the answer very short. 7.32. 